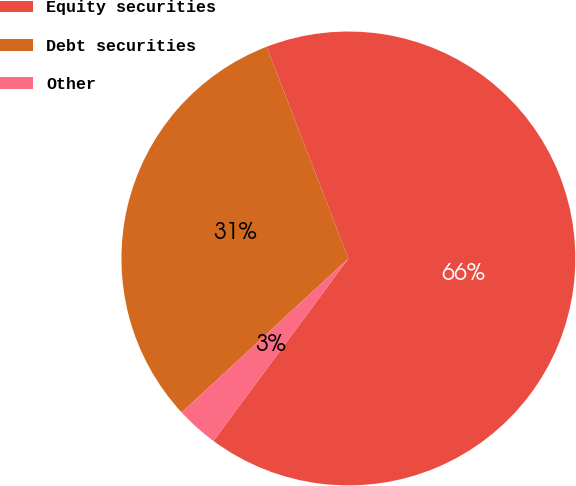Convert chart to OTSL. <chart><loc_0><loc_0><loc_500><loc_500><pie_chart><fcel>Equity securities<fcel>Debt securities<fcel>Other<nl><fcel>66.0%<fcel>31.0%<fcel>3.0%<nl></chart> 